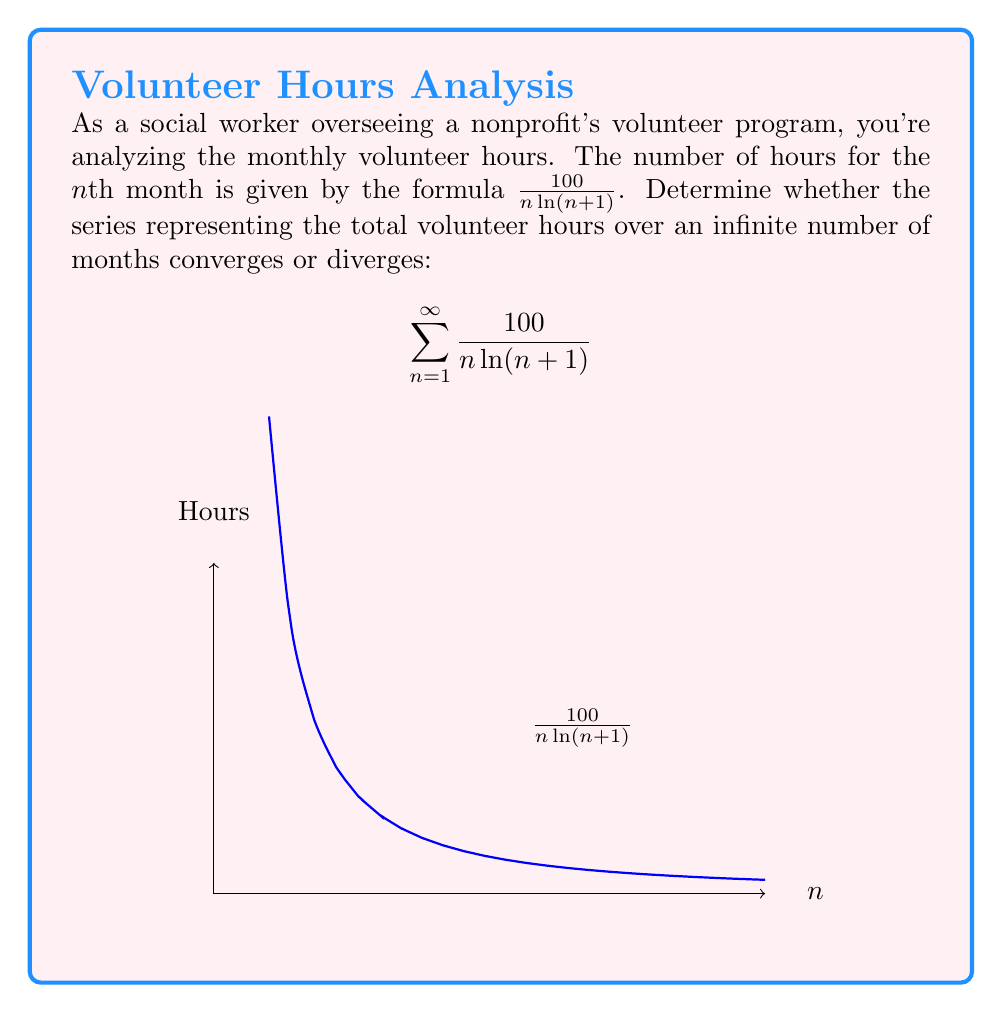Show me your answer to this math problem. To determine the convergence of this series, we'll use the integral test:

1) First, let $f(x) = \frac{100}{x\ln(x+1)}$. This function is positive, decreasing, and continuous for $x \geq 1$.

2) We'll examine the improper integral:

   $$\int_1^{\infty} \frac{100}{x\ln(x+1)} dx$$

3) Let $u = \ln(x+1)$, then $du = \frac{1}{x+1}dx$, or $dx = (x+1)du$

4) As $x \to \infty$, $u \to \infty$, and as $x \to 1$, $u \to \ln(2)$

5) Substituting:

   $$\int_{\ln(2)}^{\infty} \frac{100}{u} \cdot \frac{x+1}{x} du$$

6) As $x \to \infty$, $\frac{x+1}{x} \to 1$, so for large $x$:

   $$\int_{\ln(2)}^{\infty} \frac{100}{u} du$$

7) This evaluates to:

   $$100 \ln(u) \bigg|_{\ln(2)}^{\infty} = \infty$$

8) Since the improper integral diverges, by the integral test, the original series also diverges.
Answer: The series diverges. 